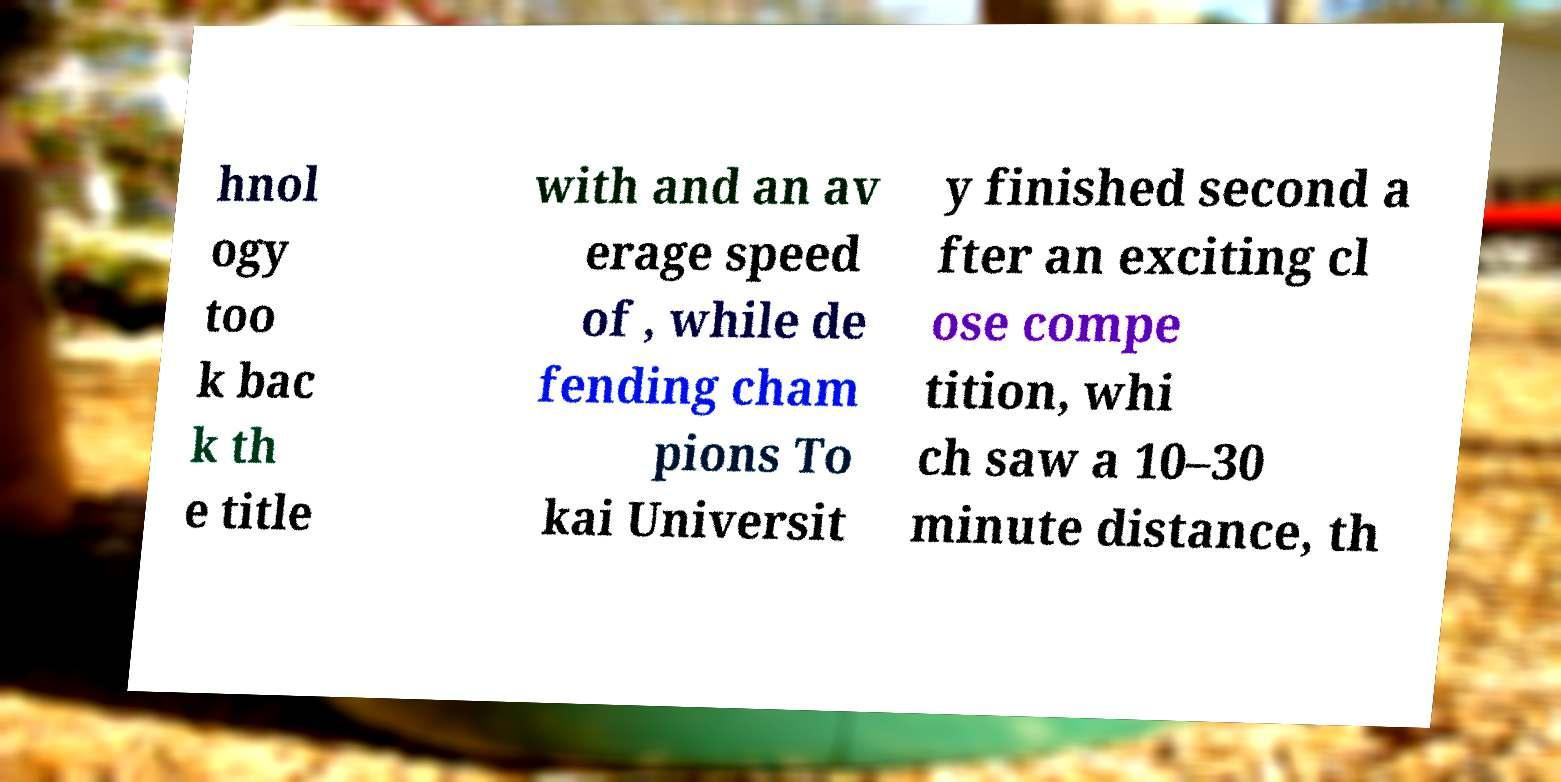There's text embedded in this image that I need extracted. Can you transcribe it verbatim? hnol ogy too k bac k th e title with and an av erage speed of , while de fending cham pions To kai Universit y finished second a fter an exciting cl ose compe tition, whi ch saw a 10–30 minute distance, th 